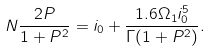Convert formula to latex. <formula><loc_0><loc_0><loc_500><loc_500>N \frac { 2 P } { 1 + P ^ { 2 } } = i _ { 0 } + \frac { 1 . 6 \Omega _ { 1 } i _ { 0 } ^ { 5 } } { \Gamma ( 1 + P ^ { 2 } ) } .</formula> 